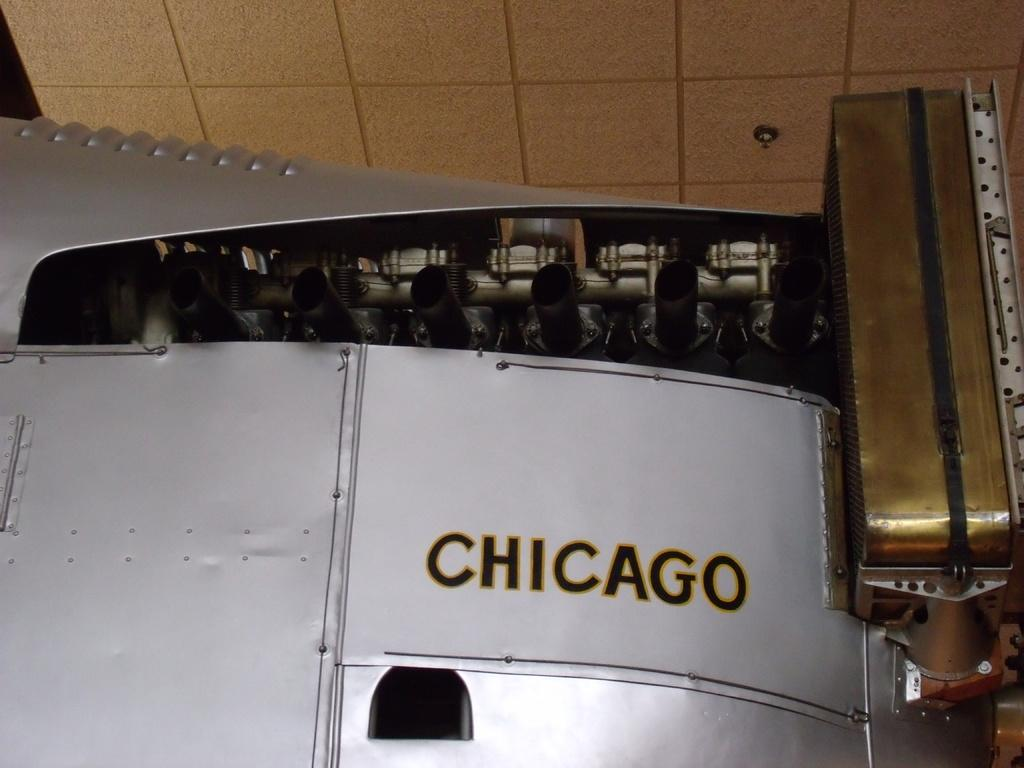<image>
Summarize the visual content of the image. Metal fridge that has the word CHICAGO on it. 